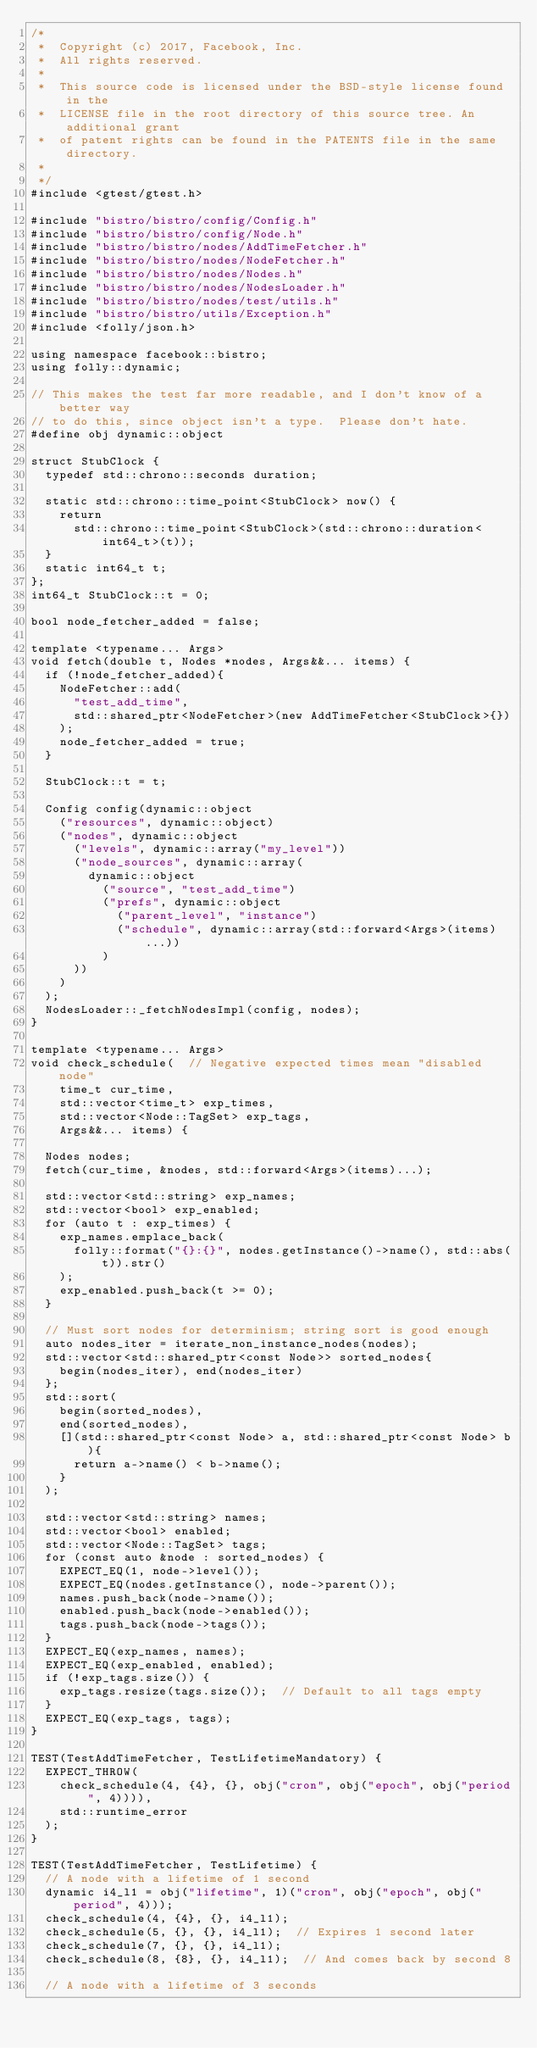Convert code to text. <code><loc_0><loc_0><loc_500><loc_500><_C++_>/*
 *  Copyright (c) 2017, Facebook, Inc.
 *  All rights reserved.
 *
 *  This source code is licensed under the BSD-style license found in the
 *  LICENSE file in the root directory of this source tree. An additional grant
 *  of patent rights can be found in the PATENTS file in the same directory.
 *
 */
#include <gtest/gtest.h>

#include "bistro/bistro/config/Config.h"
#include "bistro/bistro/config/Node.h"
#include "bistro/bistro/nodes/AddTimeFetcher.h"
#include "bistro/bistro/nodes/NodeFetcher.h"
#include "bistro/bistro/nodes/Nodes.h"
#include "bistro/bistro/nodes/NodesLoader.h"
#include "bistro/bistro/nodes/test/utils.h"
#include "bistro/bistro/utils/Exception.h"
#include <folly/json.h>

using namespace facebook::bistro;
using folly::dynamic;

// This makes the test far more readable, and I don't know of a better way
// to do this, since object isn't a type.  Please don't hate.
#define obj dynamic::object

struct StubClock {
  typedef std::chrono::seconds duration;

  static std::chrono::time_point<StubClock> now() {
    return
      std::chrono::time_point<StubClock>(std::chrono::duration<int64_t>(t));
  }
  static int64_t t;
};
int64_t StubClock::t = 0;

bool node_fetcher_added = false;

template <typename... Args>
void fetch(double t, Nodes *nodes, Args&&... items) {
  if (!node_fetcher_added){
    NodeFetcher::add(
      "test_add_time",
      std::shared_ptr<NodeFetcher>(new AddTimeFetcher<StubClock>{})
    );
    node_fetcher_added = true;
  }

  StubClock::t = t;

  Config config(dynamic::object
    ("resources", dynamic::object)
    ("nodes", dynamic::object
      ("levels", dynamic::array("my_level"))
      ("node_sources", dynamic::array(
        dynamic::object
          ("source", "test_add_time")
          ("prefs", dynamic::object
            ("parent_level", "instance")
            ("schedule", dynamic::array(std::forward<Args>(items)...))
          )
      ))
    )
  );
  NodesLoader::_fetchNodesImpl(config, nodes);
}

template <typename... Args>
void check_schedule(  // Negative expected times mean "disabled node"
    time_t cur_time,
    std::vector<time_t> exp_times,
    std::vector<Node::TagSet> exp_tags,
    Args&&... items) {

  Nodes nodes;
  fetch(cur_time, &nodes, std::forward<Args>(items)...);

  std::vector<std::string> exp_names;
  std::vector<bool> exp_enabled;
  for (auto t : exp_times) {
    exp_names.emplace_back(
      folly::format("{}:{}", nodes.getInstance()->name(), std::abs(t)).str()
    );
    exp_enabled.push_back(t >= 0);
  }

  // Must sort nodes for determinism; string sort is good enough
  auto nodes_iter = iterate_non_instance_nodes(nodes);
  std::vector<std::shared_ptr<const Node>> sorted_nodes{
    begin(nodes_iter), end(nodes_iter)
  };
  std::sort(
    begin(sorted_nodes),
    end(sorted_nodes),
    [](std::shared_ptr<const Node> a, std::shared_ptr<const Node> b){
      return a->name() < b->name();
    }
  );

  std::vector<std::string> names;
  std::vector<bool> enabled;
  std::vector<Node::TagSet> tags;
  for (const auto &node : sorted_nodes) {
    EXPECT_EQ(1, node->level());
    EXPECT_EQ(nodes.getInstance(), node->parent());
    names.push_back(node->name());
    enabled.push_back(node->enabled());
    tags.push_back(node->tags());
  }
  EXPECT_EQ(exp_names, names);
  EXPECT_EQ(exp_enabled, enabled);
  if (!exp_tags.size()) {
    exp_tags.resize(tags.size());  // Default to all tags empty
  }
  EXPECT_EQ(exp_tags, tags);
}

TEST(TestAddTimeFetcher, TestLifetimeMandatory) {
  EXPECT_THROW(
    check_schedule(4, {4}, {}, obj("cron", obj("epoch", obj("period", 4)))),
    std::runtime_error
  );
}

TEST(TestAddTimeFetcher, TestLifetime) {
  // A node with a lifetime of 1 second
  dynamic i4_l1 = obj("lifetime", 1)("cron", obj("epoch", obj("period", 4)));
  check_schedule(4, {4}, {}, i4_l1);
  check_schedule(5, {}, {}, i4_l1);  // Expires 1 second later
  check_schedule(7, {}, {}, i4_l1);
  check_schedule(8, {8}, {}, i4_l1);  // And comes back by second 8

  // A node with a lifetime of 3 seconds</code> 